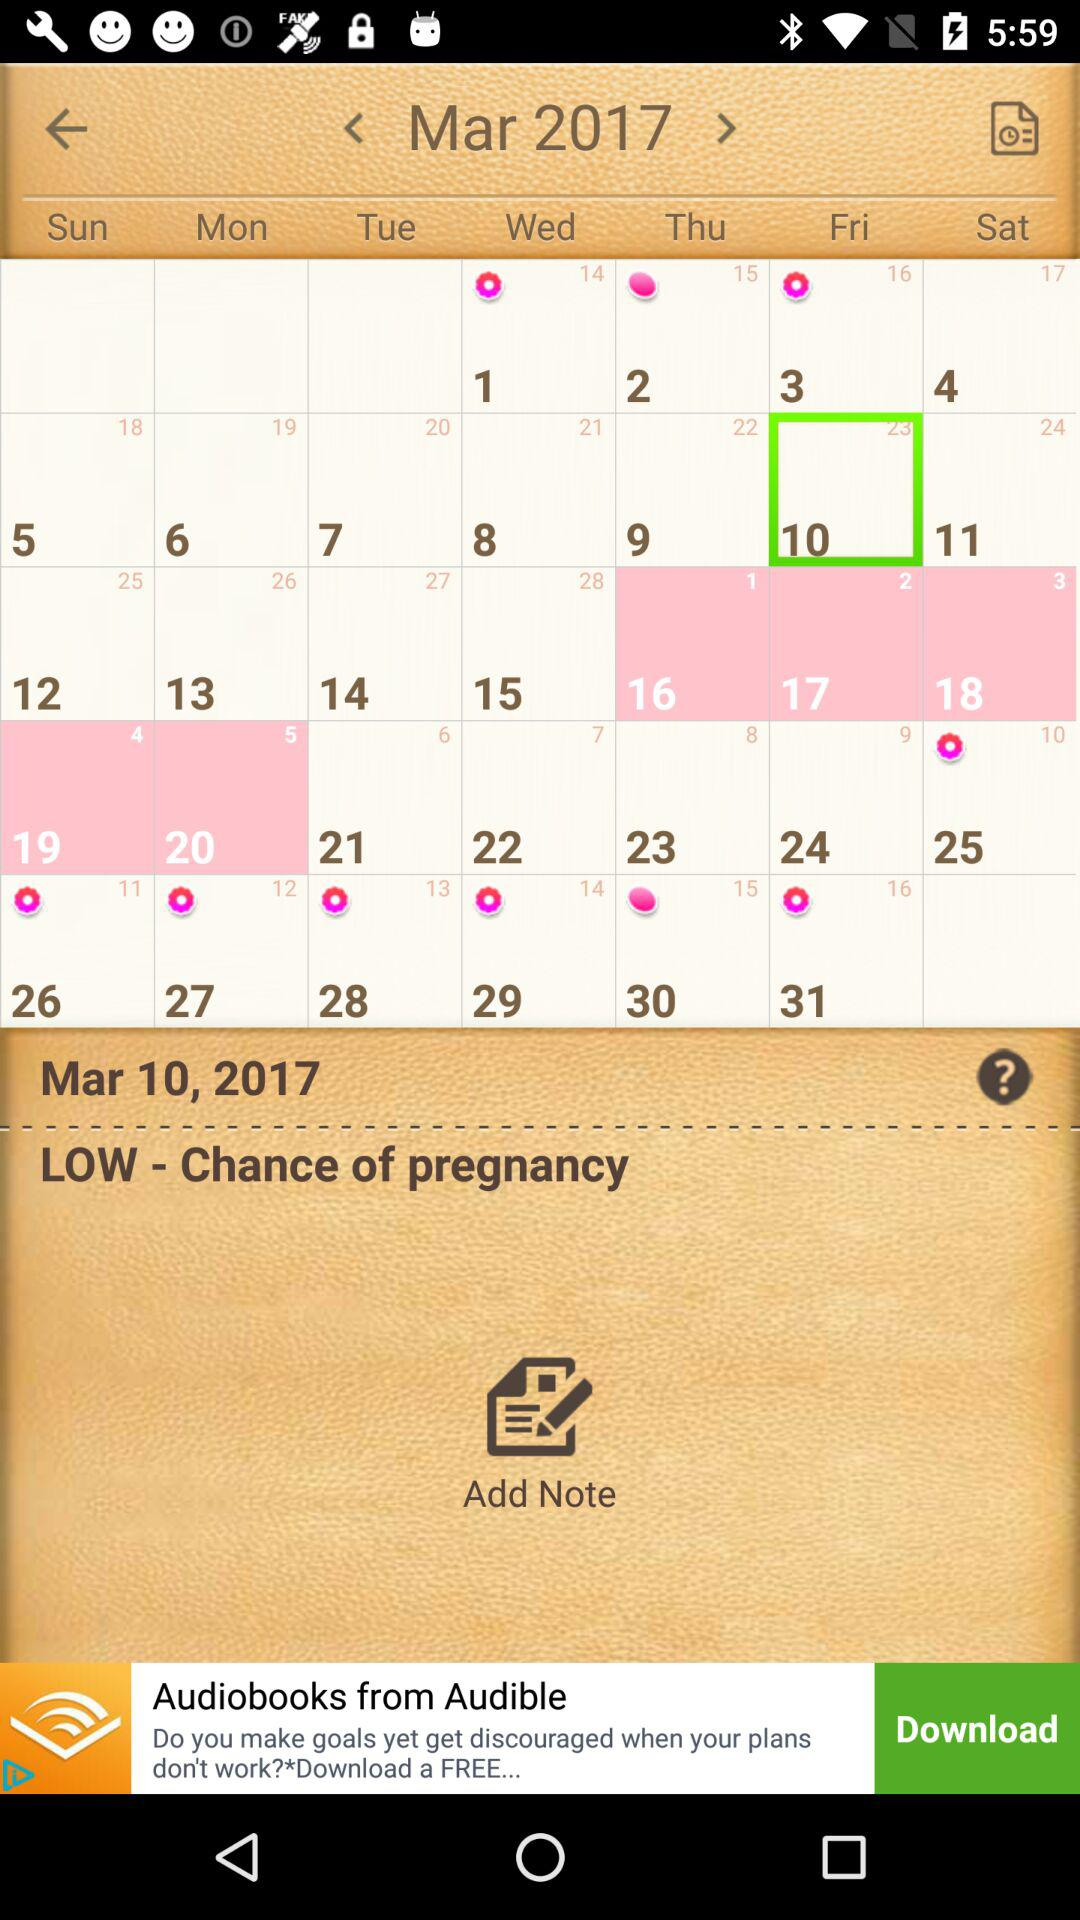What is the day of the selected date? The day is Friday. 